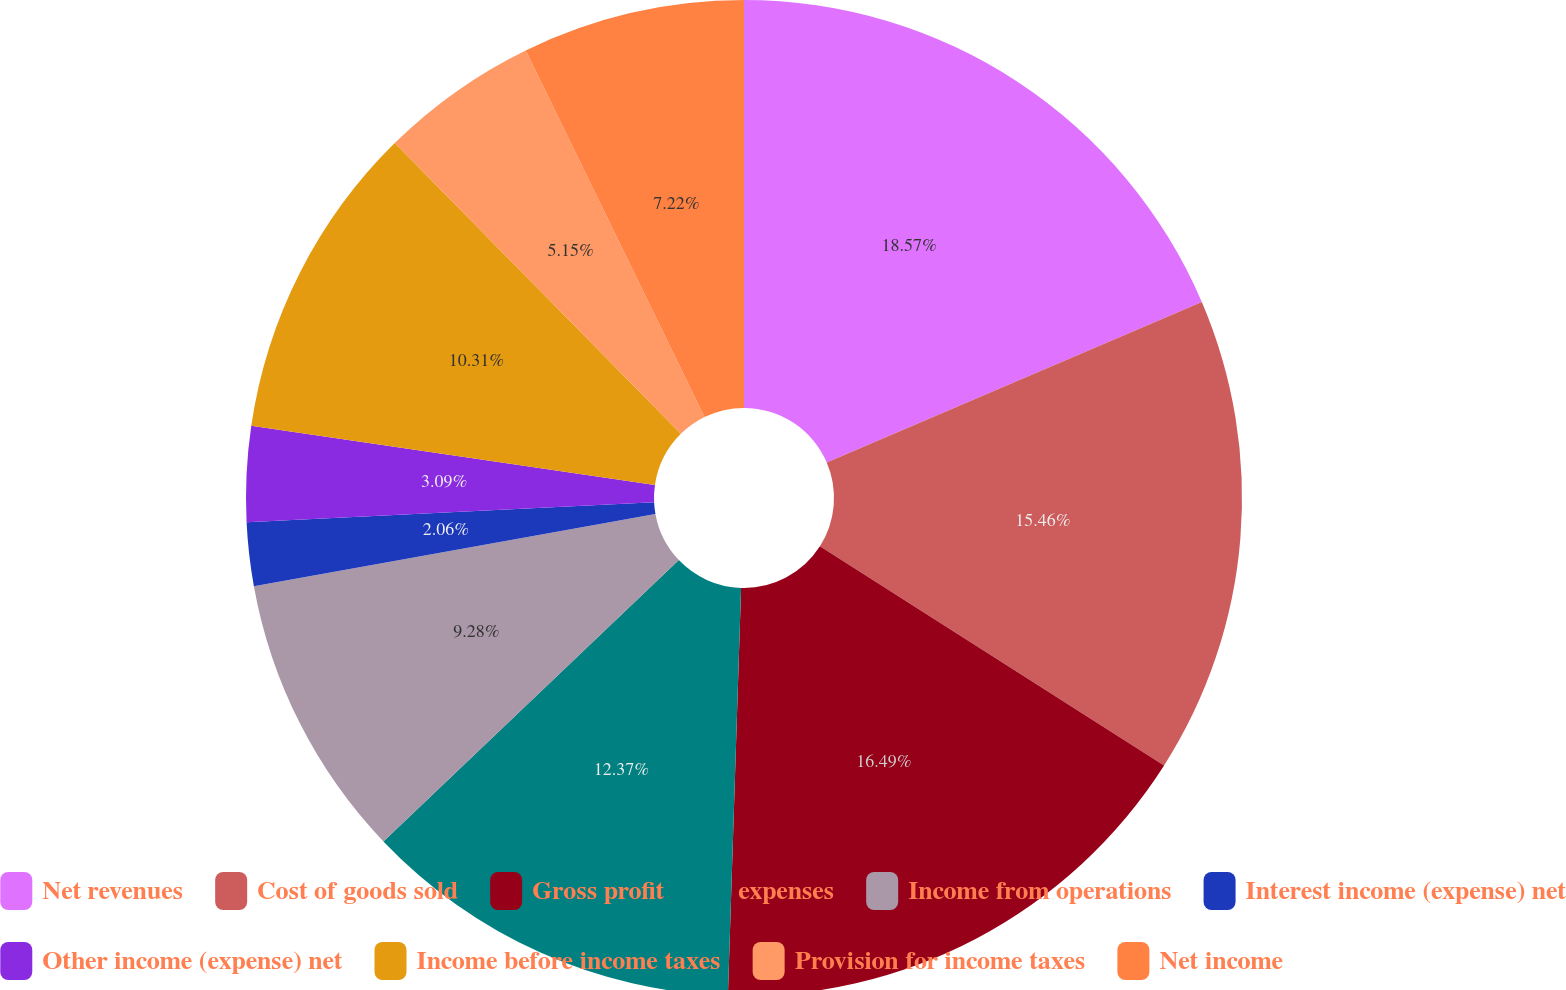<chart> <loc_0><loc_0><loc_500><loc_500><pie_chart><fcel>Net revenues<fcel>Cost of goods sold<fcel>Gross profit<fcel>expenses<fcel>Income from operations<fcel>Interest income (expense) net<fcel>Other income (expense) net<fcel>Income before income taxes<fcel>Provision for income taxes<fcel>Net income<nl><fcel>18.56%<fcel>15.46%<fcel>16.49%<fcel>12.37%<fcel>9.28%<fcel>2.06%<fcel>3.09%<fcel>10.31%<fcel>5.15%<fcel>7.22%<nl></chart> 